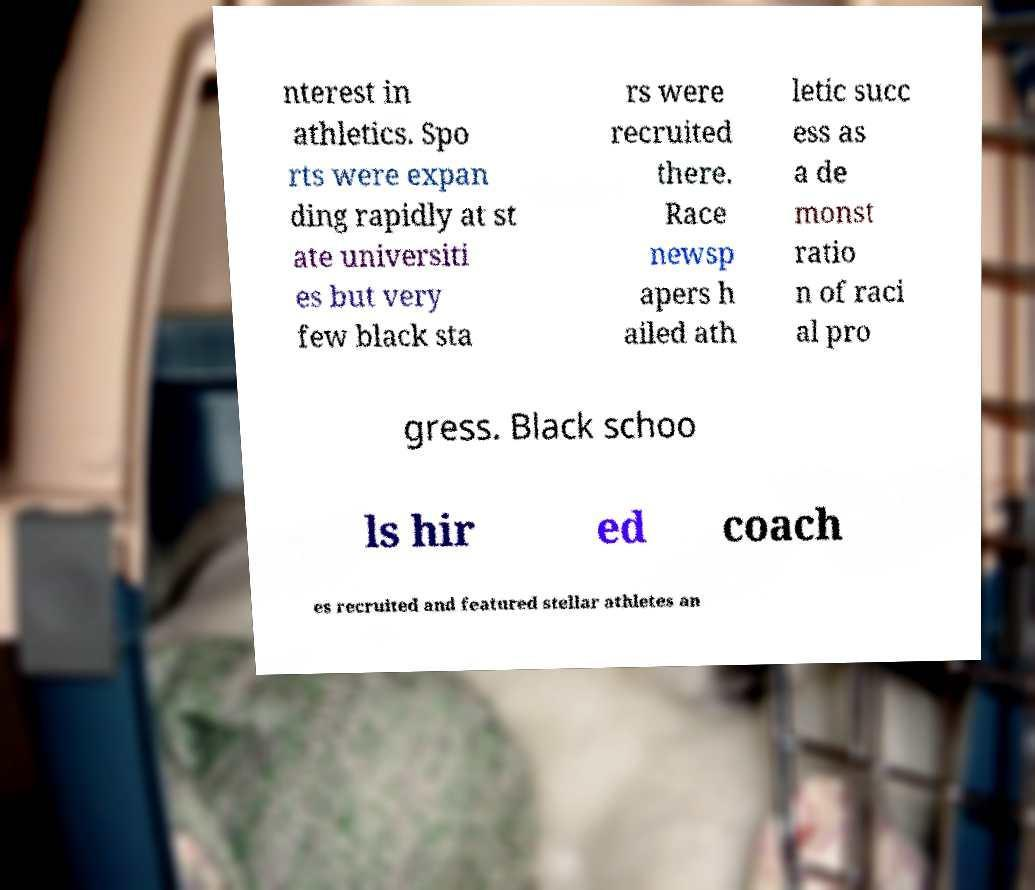Can you read and provide the text displayed in the image?This photo seems to have some interesting text. Can you extract and type it out for me? nterest in athletics. Spo rts were expan ding rapidly at st ate universiti es but very few black sta rs were recruited there. Race newsp apers h ailed ath letic succ ess as a de monst ratio n of raci al pro gress. Black schoo ls hir ed coach es recruited and featured stellar athletes an 